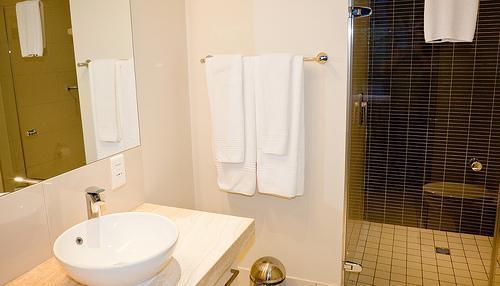How many large towels are shown?
Give a very brief answer. 3. How many towels are hanging next to the sink?
Give a very brief answer. 4. 